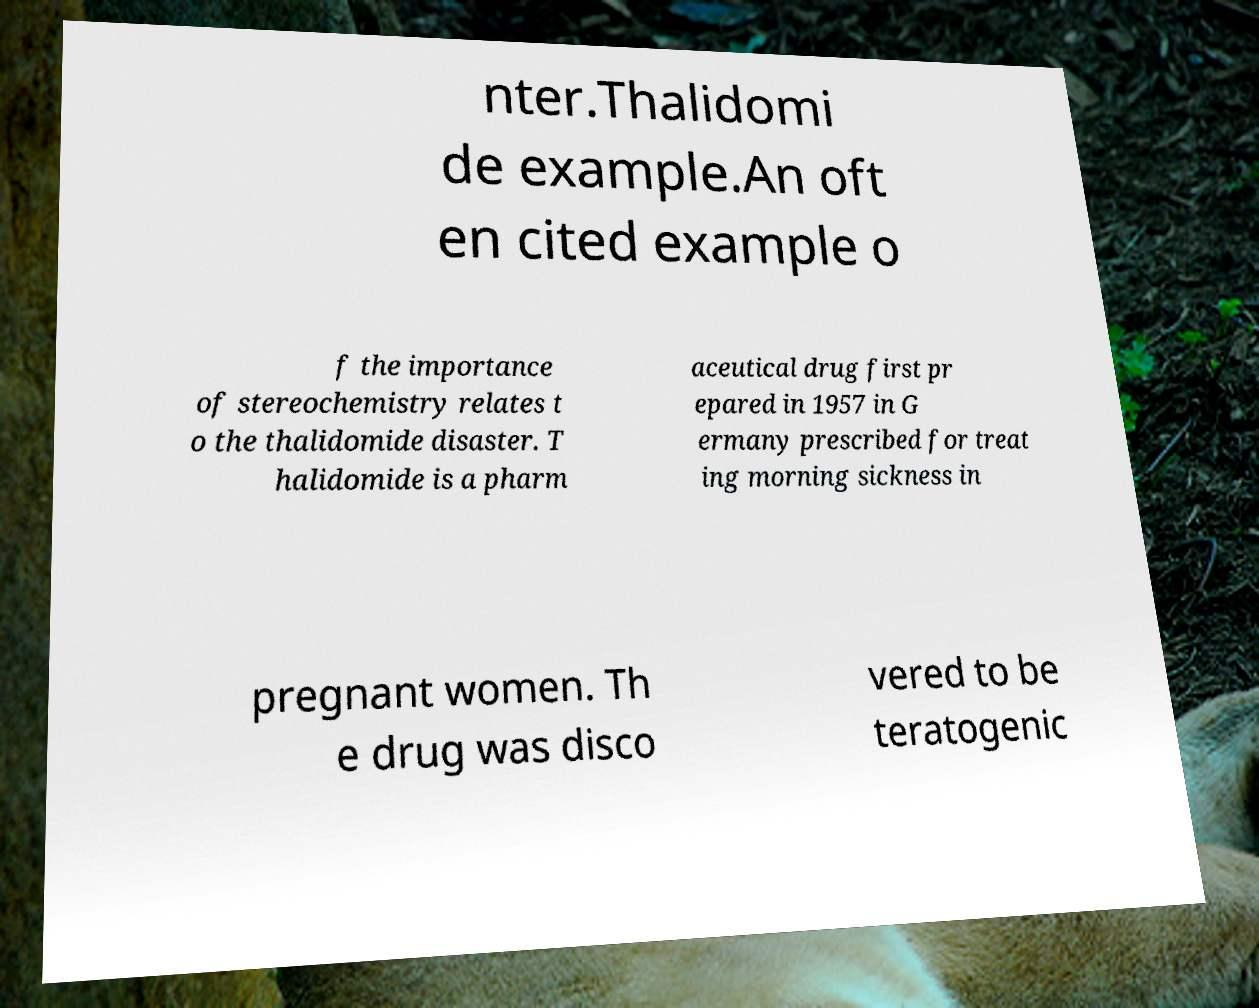Can you accurately transcribe the text from the provided image for me? nter.Thalidomi de example.An oft en cited example o f the importance of stereochemistry relates t o the thalidomide disaster. T halidomide is a pharm aceutical drug first pr epared in 1957 in G ermany prescribed for treat ing morning sickness in pregnant women. Th e drug was disco vered to be teratogenic 